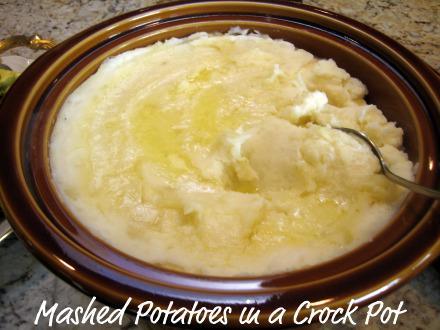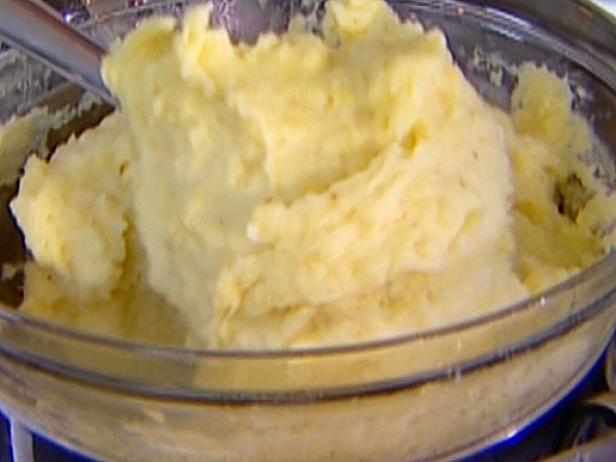The first image is the image on the left, the second image is the image on the right. Analyze the images presented: Is the assertion "At least one serving of mashed potato is presented in clear, round glass bowl." valid? Answer yes or no. Yes. The first image is the image on the left, the second image is the image on the right. Examine the images to the left and right. Is the description "There is an eating utensil in a bowl of mashed potatoes." accurate? Answer yes or no. Yes. 